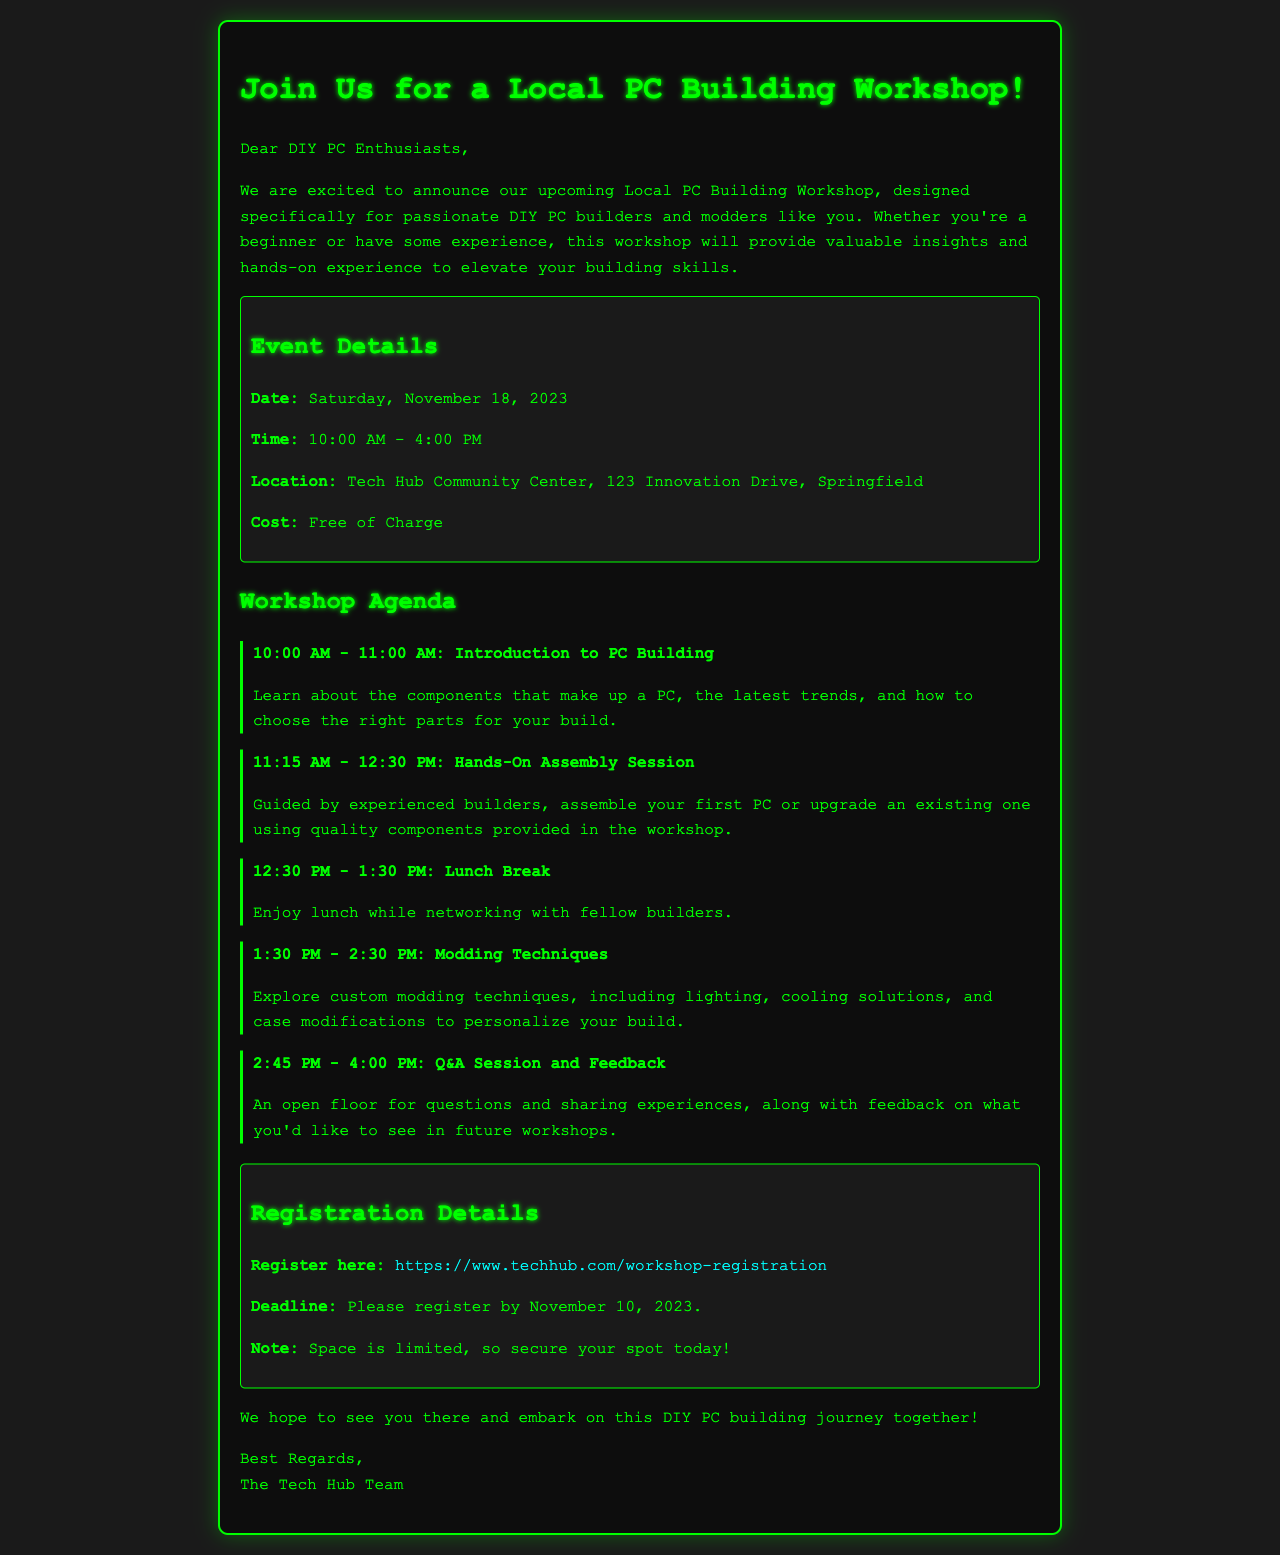What is the date of the workshop? The date of the workshop is explicitly mentioned in the event details section.
Answer: Saturday, November 18, 2023 What is the location of the event? The location is provided in the event details within the document.
Answer: Tech Hub Community Center, 123 Innovation Drive, Springfield Is there a cost to attend the workshop? The cost is clearly stated in the event details section of the document.
Answer: Free of Charge What time does the workshop start? The starting time is specified in the event details section.
Answer: 10:00 AM When is the registration deadline? The deadline for registration is mentioned in the registration details section.
Answer: November 10, 2023 What activity follows the lunch break in the agenda? The activity right after the lunch break is stated in the agenda section of the document.
Answer: Modding Techniques How long is the lunch break? The duration of the lunch break can be found in the agenda section.
Answer: 1 hour What portion of the workshop is dedicated to Q&A? The agenda specifies the time allocated for the Q&A session.
Answer: 1 hour 15 minutes What type of skills will the workshop enhance? The document highlights skills that will be improved throughout the workshop.
Answer: Building skills 